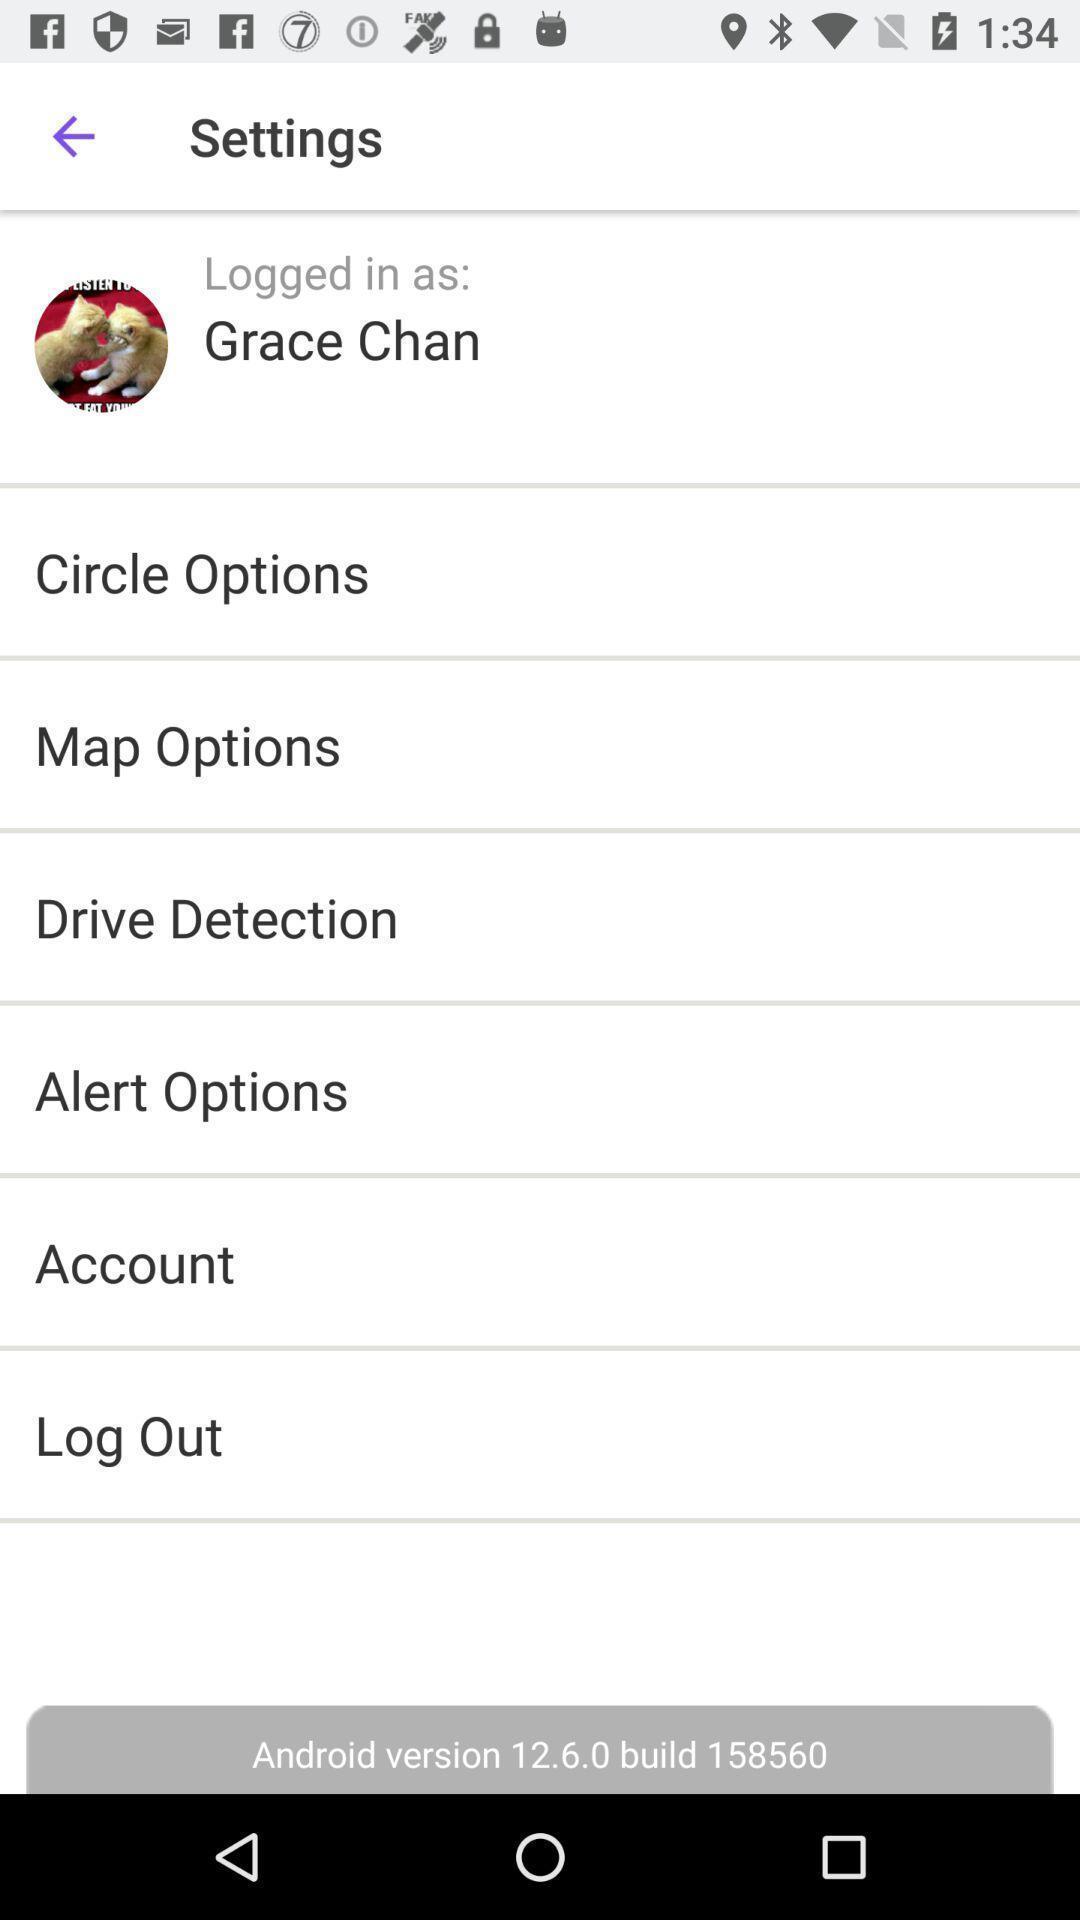Provide a description of this screenshot. Settings page of connections application. 